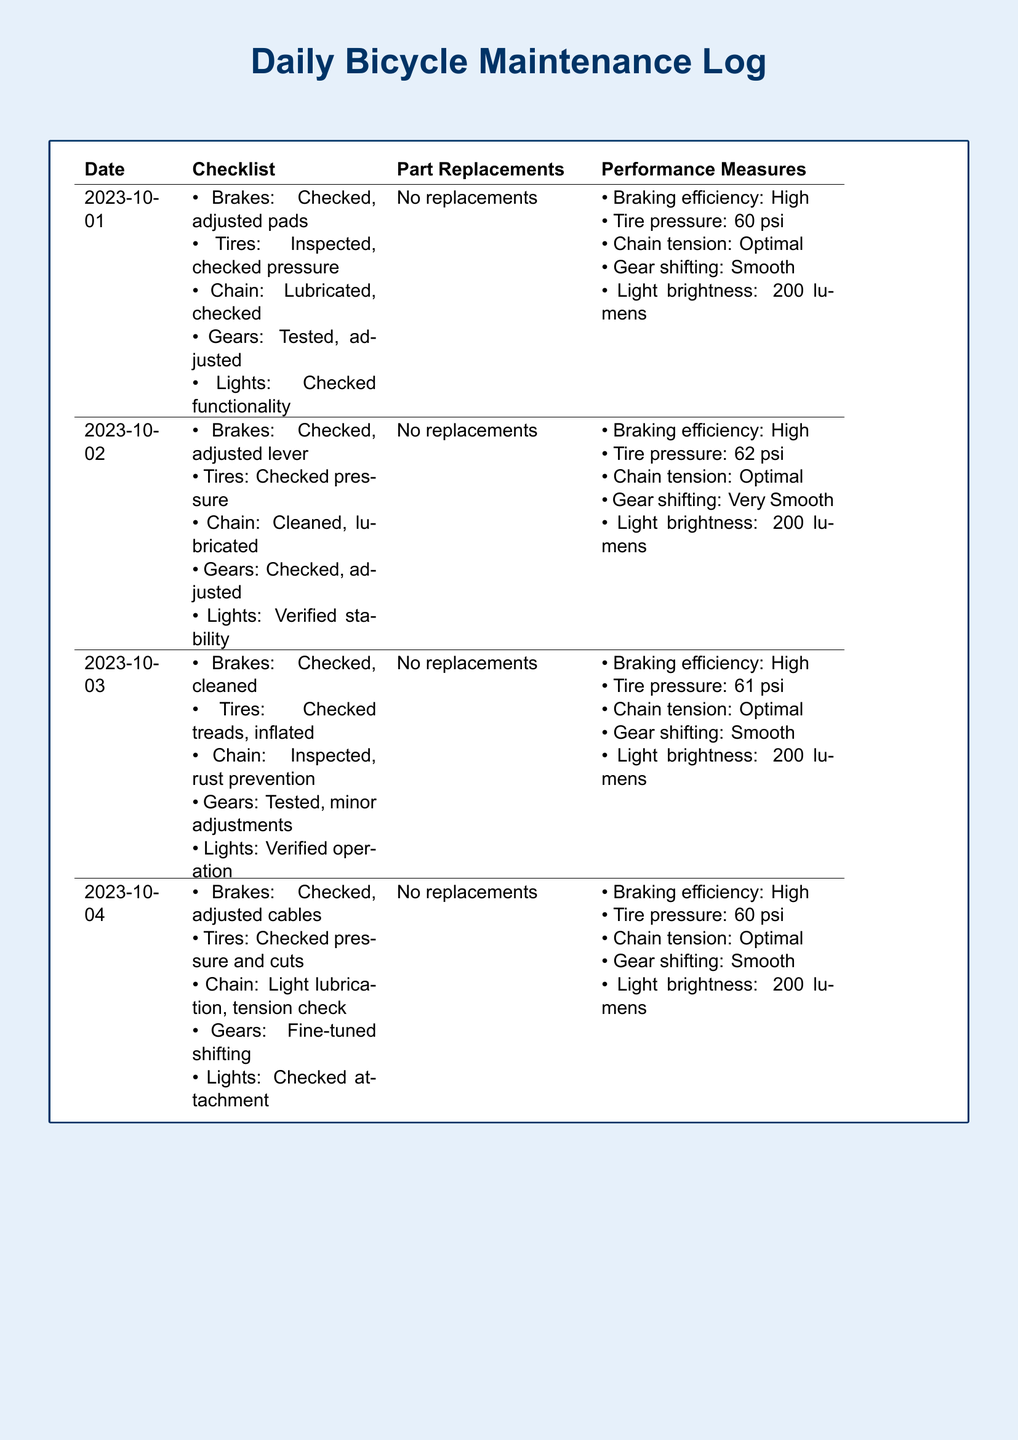What date was the first entry logged? The first entry in the daily maintenance log is dated October 1, 2023.
Answer: October 1, 2023 How many times were part replacements noted? The document indicates there were no part replacements recorded throughout the 30-day period.
Answer: No replacements What is the tire pressure on October 2? The tire pressure noted for October 2 was 62 psi.
Answer: 62 psi Which date did gear shifting improve to "Very Smooth"? The improvement in gear shifting to "Very Smooth" was recorded on October 2, 2023.
Answer: October 2, 2023 What was the constant light brightness measured throughout the log? The light brightness remained constant at 200 lumens according to the data analysis notes.
Answer: 200 lumens On how many days was the braking efficiency listed as "High"? Braking efficiency was reported as "High" for all entries logging throughout the period.
Answer: 4 days Which part of the bicycle was cleaned and lubricated on October 2? On October 2, the chain was noted as cleaned and lubricated.
Answer: Chain What maintenance check was performed for the tires on October 3? The tires were checked for treads and inflated on October 3.
Answer: Checked treads, inflated What was the initial chain tension status on October 1? The chain tension status was reported as "Optimal" on October 1.
Answer: Optimal 